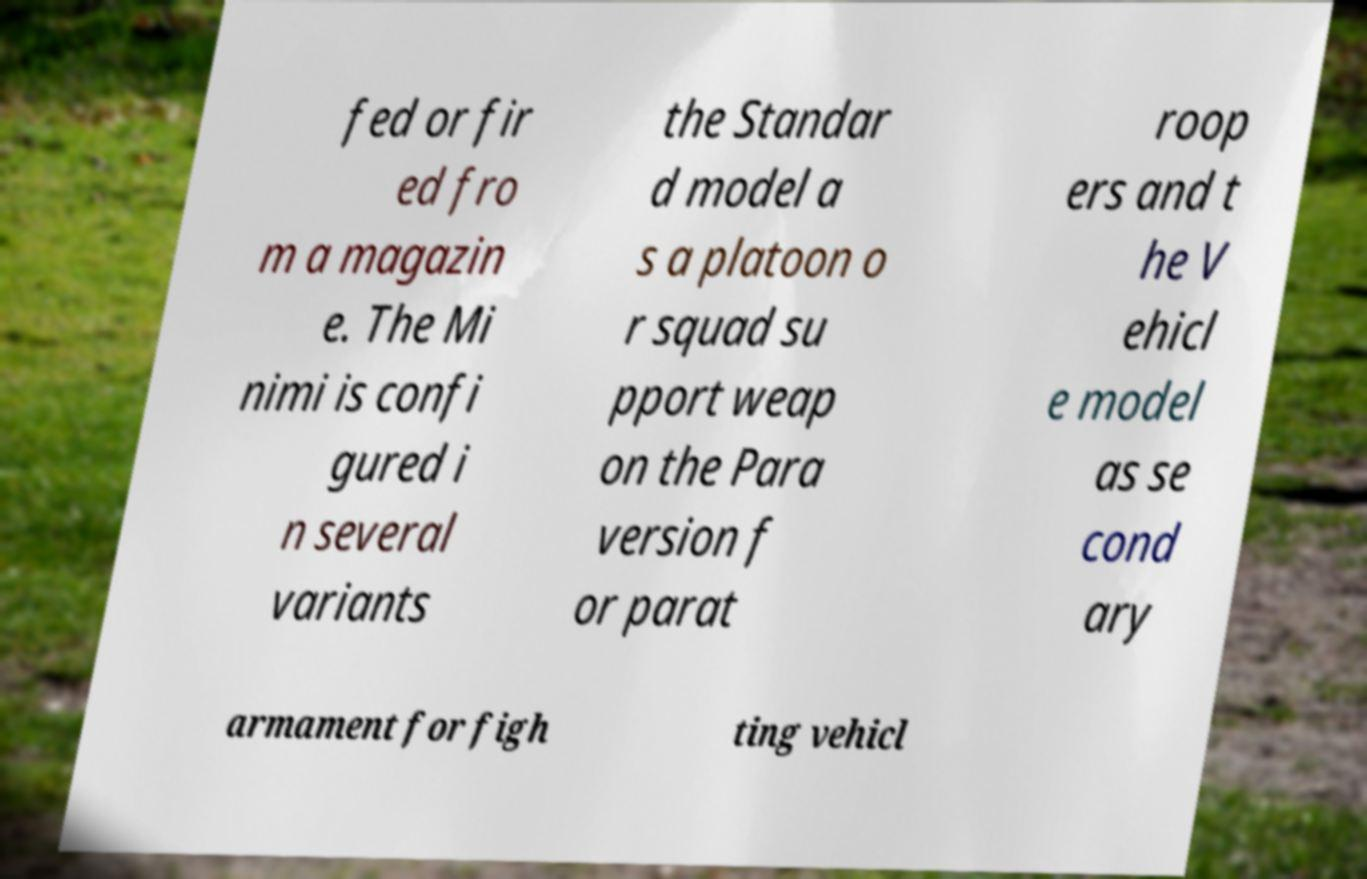Can you read and provide the text displayed in the image?This photo seems to have some interesting text. Can you extract and type it out for me? fed or fir ed fro m a magazin e. The Mi nimi is confi gured i n several variants the Standar d model a s a platoon o r squad su pport weap on the Para version f or parat roop ers and t he V ehicl e model as se cond ary armament for figh ting vehicl 